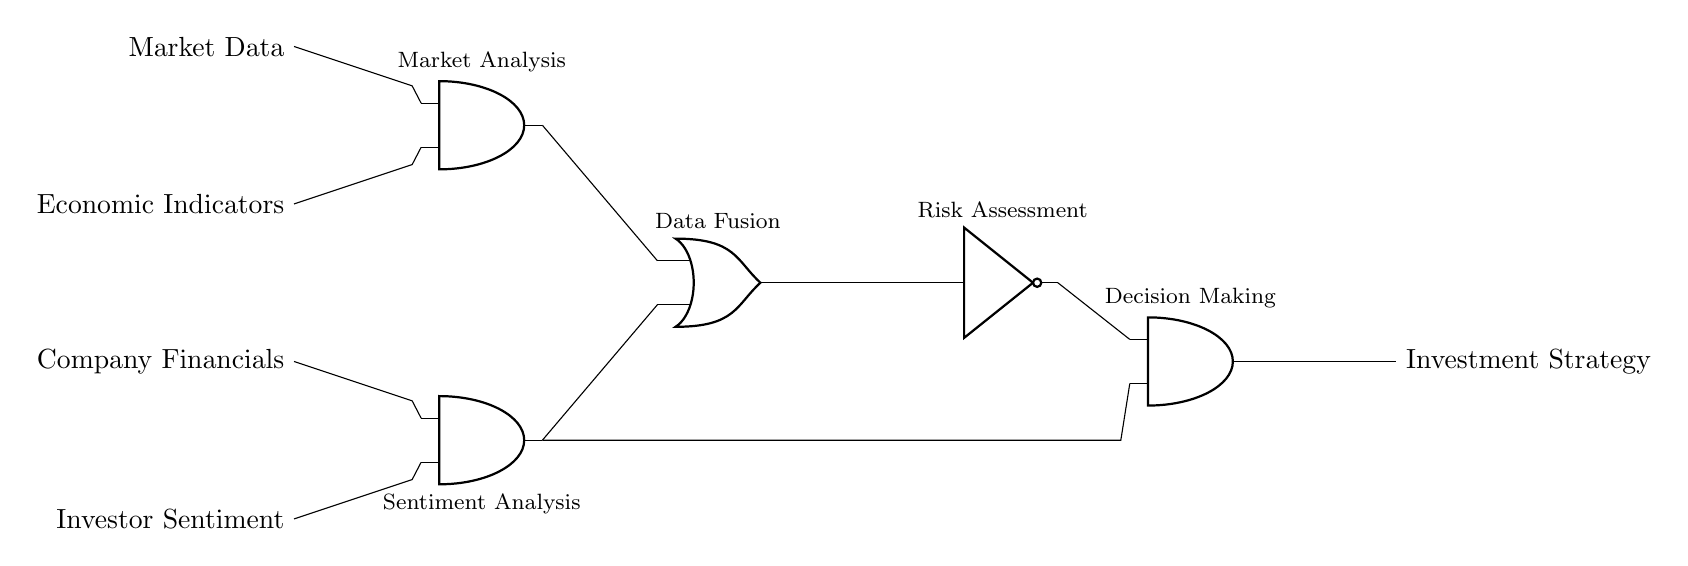What are the inputs to the circuit? The inputs are market data, economic indicators, company financials, and investor sentiment, as labeled on the left side of the diagram.
Answer: Market Data, Economic Indicators, Company Financials, Investor Sentiment What type of logic gate is used at the top? The gate at the top is an AND gate, which is indicated by the shape and label in the diagram. It takes multiple inputs and produces an output only when all inputs are high.
Answer: AND What is the function of the NOT gate in this circuit? The NOT gate, labeled as 'Risk Assessment', inverts the output of the OR gate, meaning it takes the data fusion result and produces the opposite value. This indicates a risk-related assessment in the investment strategy.
Answer: Inversion How many AND gates are present in the circuit? There are three AND gates illustrated in the circuit, with two on the left side and one on the right side that determines the final investment strategy output.
Answer: Three What is the role of the OR gate in this network? The OR gate, labeled as 'Data Fusion', combines the outputs of the two AND gates from the market analysis and sentiment analysis. It produces an output if at least one of the inputs is high, facilitating data integration for decision-making.
Answer: Data Fusion What is the final output of the circuit? The final output is the investment strategy, as indicated on the right side of the diagram, which results from the processing through the various gates.
Answer: Investment Strategy 